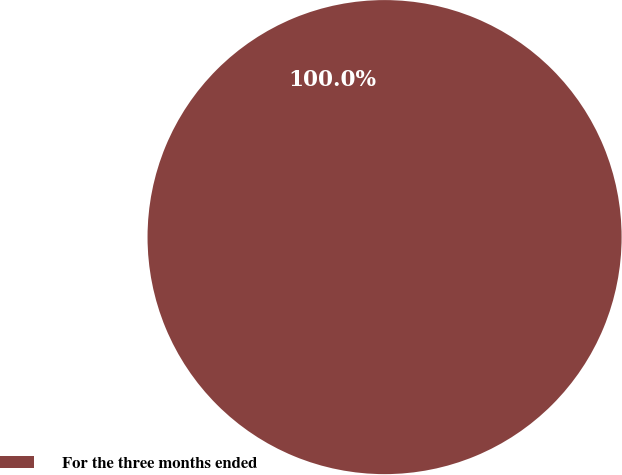Convert chart to OTSL. <chart><loc_0><loc_0><loc_500><loc_500><pie_chart><fcel>For the three months ended<nl><fcel>100.0%<nl></chart> 